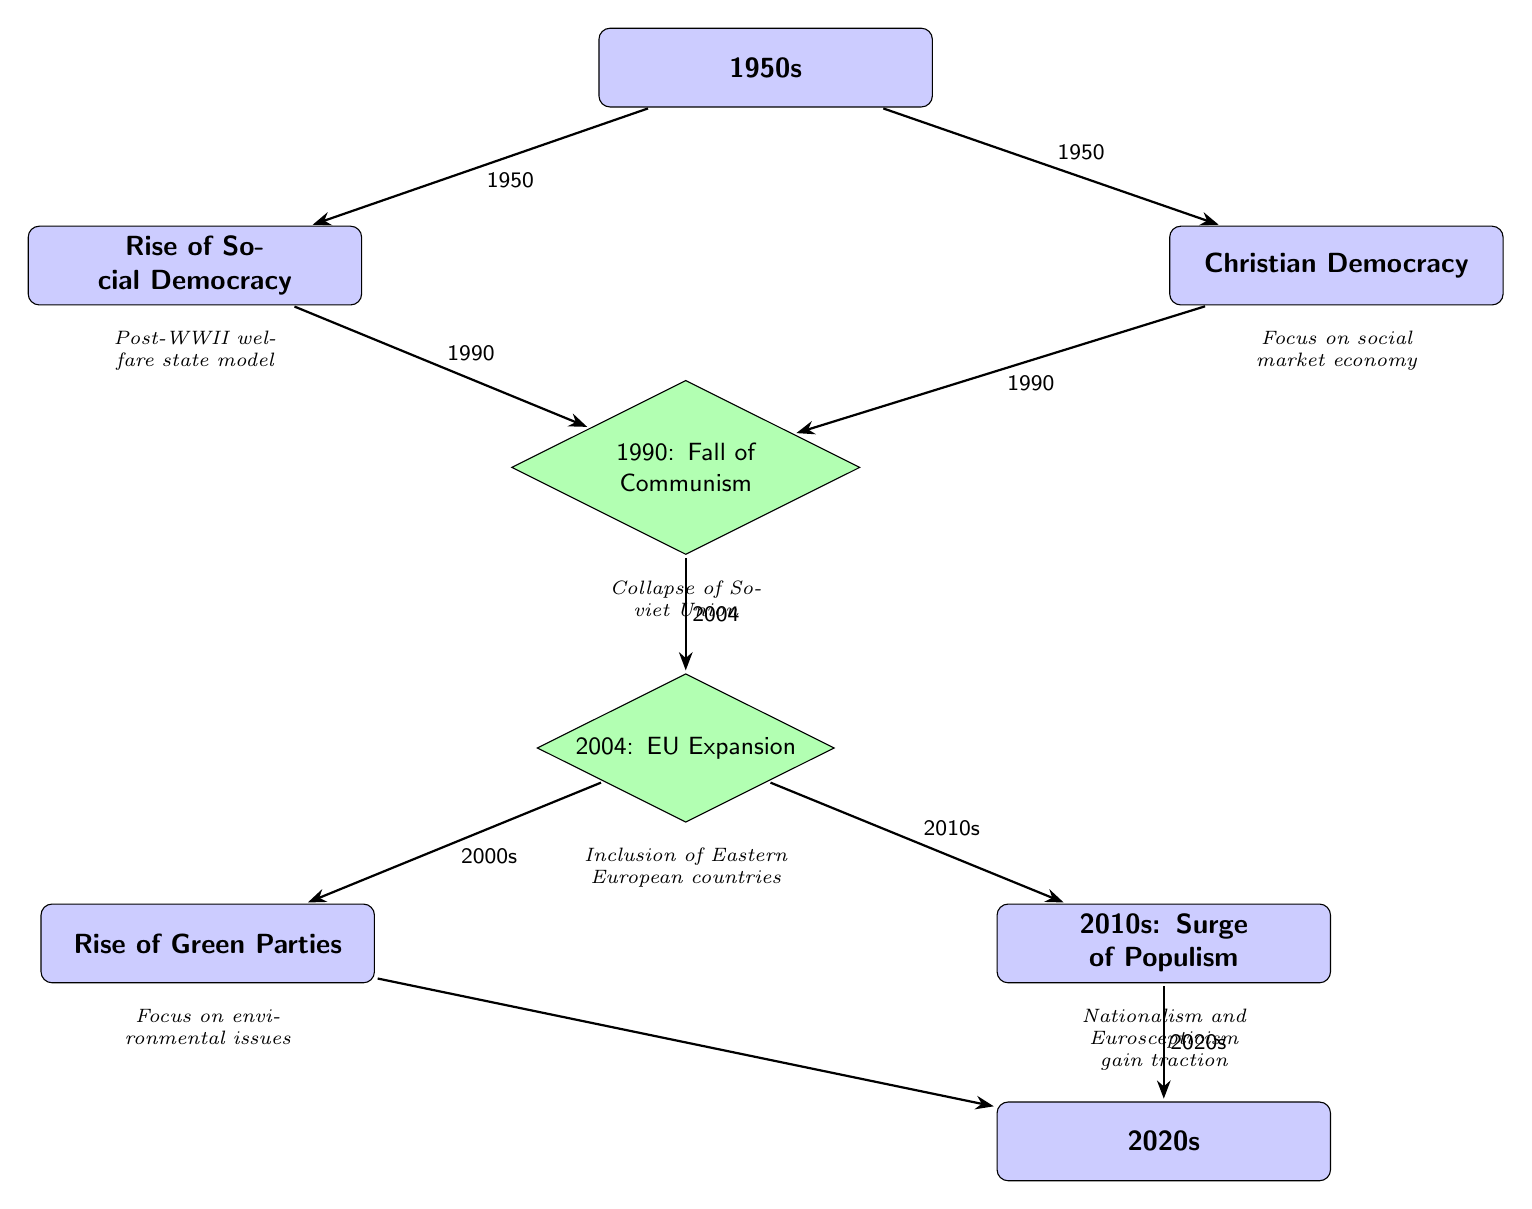What major political ideologies emerged in the 1950s in Europe? The diagram shows two nodes connected to the initial "1950s" event: "Rise of Social Democracy" and "Christian Democracy." This indicates that both were significant political ideologies that emerged during that decade.
Answer: Rise of Social Democracy, Christian Democracy What significant event occurred in 1990? There is a milestone node labeled "1990: Fall of Communism," indicating that this specific year marks an important transformation in the political landscape of Europe, particularly regarding communism.
Answer: Fall of Communism What political trend gained momentum in the 2010s according to the diagram? The diagram has a node titled "2010s: Surge of Populism" that highlights the increase in populist movements during this decade, which is also represented in connection to the EU Expansion milestone.
Answer: Surge of Populism How many main events are recorded in this diagram? By counting the milestone nodes and considering the initial and final events represented, we can identify one starting point (1950s), four key milestones (Fall of Communism, EU Expansion, and two additional trends), leading to a total of seven significant events.
Answer: Seven What do the green parties focus on according to the diagram? There is a node labeled "Rise of Green Parties," which is described below as "Focus on environmental issues," demonstrating that environmental concerns are central to their political agenda.
Answer: Environmental issues What notable transformation did Eastern Europe undergo in 2004? The milestone "2004: EU Expansion" indicates a significant transformation for Eastern Europe, as this event represents the inclusion of Eastern European countries into the European Union.
Answer: Inclusion of Eastern European countries What political shift is represented by the edges from the EU Expansion node? The diagram shows two edges going out from "2004: EU Expansion" node, leading to "Rise of Green Parties" and "2010s: Surge of Populism." This indicates that after EU Expansion, both green politics and populist movements gained relevance.
Answer: Rise of Green Parties, Surge of Populism What is the relationship between Social Democracy and Christian Democracy in the context of the 1990 milestone? The diagram displays both ideologies originating from the "1950s" node and connecting to the "1990: Fall of Communism" milestone, indicating that both were affected by or responded to the changes that occurred during that period.
Answer: Both connected to Fall of Communism What aspect of political dynamics does the edge from "Rise of Green Parties" to the present node depict? The connection indicates that the rise of green parties has a continuous presence in the political landscape and extends into the 2020s, suggesting an ongoing relevance of environmental issues.
Answer: Ongoing relevance of environmental issues 